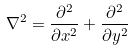<formula> <loc_0><loc_0><loc_500><loc_500>\nabla ^ { 2 } = \frac { \partial ^ { 2 } } { \partial x ^ { 2 } } + \frac { \partial ^ { 2 } } { \partial y ^ { 2 } }</formula> 